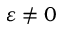Convert formula to latex. <formula><loc_0><loc_0><loc_500><loc_500>\varepsilon \ne 0</formula> 